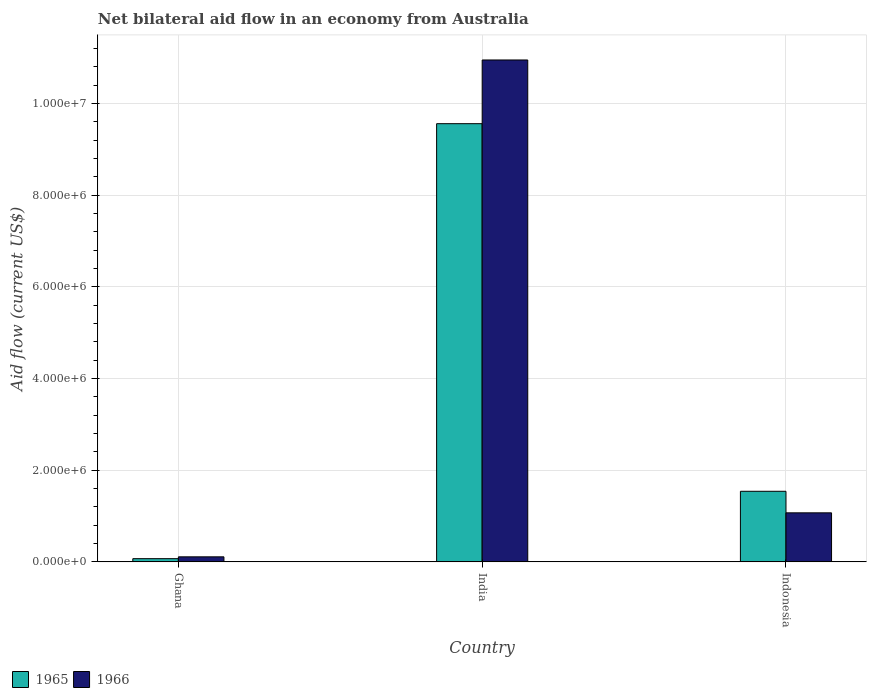How many groups of bars are there?
Provide a succinct answer. 3. What is the label of the 3rd group of bars from the left?
Your answer should be very brief. Indonesia. In how many cases, is the number of bars for a given country not equal to the number of legend labels?
Give a very brief answer. 0. What is the net bilateral aid flow in 1966 in India?
Provide a short and direct response. 1.10e+07. Across all countries, what is the maximum net bilateral aid flow in 1965?
Provide a short and direct response. 9.56e+06. Across all countries, what is the minimum net bilateral aid flow in 1965?
Provide a succinct answer. 7.00e+04. What is the total net bilateral aid flow in 1965 in the graph?
Provide a short and direct response. 1.12e+07. What is the difference between the net bilateral aid flow in 1965 in India and that in Indonesia?
Keep it short and to the point. 8.02e+06. What is the difference between the net bilateral aid flow in 1965 in Indonesia and the net bilateral aid flow in 1966 in India?
Provide a succinct answer. -9.41e+06. What is the average net bilateral aid flow in 1966 per country?
Your answer should be very brief. 4.04e+06. What is the difference between the net bilateral aid flow of/in 1966 and net bilateral aid flow of/in 1965 in Ghana?
Give a very brief answer. 4.00e+04. What is the ratio of the net bilateral aid flow in 1965 in Ghana to that in Indonesia?
Give a very brief answer. 0.05. Is the difference between the net bilateral aid flow in 1966 in Ghana and Indonesia greater than the difference between the net bilateral aid flow in 1965 in Ghana and Indonesia?
Make the answer very short. Yes. What is the difference between the highest and the second highest net bilateral aid flow in 1965?
Provide a short and direct response. 9.49e+06. What is the difference between the highest and the lowest net bilateral aid flow in 1966?
Your answer should be very brief. 1.08e+07. Is the sum of the net bilateral aid flow in 1966 in Ghana and India greater than the maximum net bilateral aid flow in 1965 across all countries?
Your answer should be compact. Yes. What does the 2nd bar from the left in India represents?
Provide a succinct answer. 1966. What does the 1st bar from the right in India represents?
Your answer should be very brief. 1966. What is the difference between two consecutive major ticks on the Y-axis?
Your response must be concise. 2.00e+06. Does the graph contain grids?
Offer a terse response. Yes. Where does the legend appear in the graph?
Keep it short and to the point. Bottom left. How are the legend labels stacked?
Ensure brevity in your answer.  Horizontal. What is the title of the graph?
Your response must be concise. Net bilateral aid flow in an economy from Australia. Does "1987" appear as one of the legend labels in the graph?
Give a very brief answer. No. What is the label or title of the X-axis?
Keep it short and to the point. Country. What is the Aid flow (current US$) in 1966 in Ghana?
Ensure brevity in your answer.  1.10e+05. What is the Aid flow (current US$) in 1965 in India?
Offer a very short reply. 9.56e+06. What is the Aid flow (current US$) in 1966 in India?
Keep it short and to the point. 1.10e+07. What is the Aid flow (current US$) of 1965 in Indonesia?
Your response must be concise. 1.54e+06. What is the Aid flow (current US$) of 1966 in Indonesia?
Give a very brief answer. 1.07e+06. Across all countries, what is the maximum Aid flow (current US$) in 1965?
Ensure brevity in your answer.  9.56e+06. Across all countries, what is the maximum Aid flow (current US$) of 1966?
Your answer should be compact. 1.10e+07. Across all countries, what is the minimum Aid flow (current US$) of 1965?
Keep it short and to the point. 7.00e+04. Across all countries, what is the minimum Aid flow (current US$) in 1966?
Your response must be concise. 1.10e+05. What is the total Aid flow (current US$) of 1965 in the graph?
Provide a short and direct response. 1.12e+07. What is the total Aid flow (current US$) in 1966 in the graph?
Give a very brief answer. 1.21e+07. What is the difference between the Aid flow (current US$) in 1965 in Ghana and that in India?
Ensure brevity in your answer.  -9.49e+06. What is the difference between the Aid flow (current US$) of 1966 in Ghana and that in India?
Your response must be concise. -1.08e+07. What is the difference between the Aid flow (current US$) of 1965 in Ghana and that in Indonesia?
Provide a succinct answer. -1.47e+06. What is the difference between the Aid flow (current US$) of 1966 in Ghana and that in Indonesia?
Make the answer very short. -9.60e+05. What is the difference between the Aid flow (current US$) of 1965 in India and that in Indonesia?
Provide a succinct answer. 8.02e+06. What is the difference between the Aid flow (current US$) in 1966 in India and that in Indonesia?
Offer a very short reply. 9.88e+06. What is the difference between the Aid flow (current US$) in 1965 in Ghana and the Aid flow (current US$) in 1966 in India?
Keep it short and to the point. -1.09e+07. What is the difference between the Aid flow (current US$) in 1965 in Ghana and the Aid flow (current US$) in 1966 in Indonesia?
Ensure brevity in your answer.  -1.00e+06. What is the difference between the Aid flow (current US$) in 1965 in India and the Aid flow (current US$) in 1966 in Indonesia?
Your answer should be compact. 8.49e+06. What is the average Aid flow (current US$) of 1965 per country?
Ensure brevity in your answer.  3.72e+06. What is the average Aid flow (current US$) of 1966 per country?
Give a very brief answer. 4.04e+06. What is the difference between the Aid flow (current US$) of 1965 and Aid flow (current US$) of 1966 in Ghana?
Provide a succinct answer. -4.00e+04. What is the difference between the Aid flow (current US$) of 1965 and Aid flow (current US$) of 1966 in India?
Offer a very short reply. -1.39e+06. What is the difference between the Aid flow (current US$) of 1965 and Aid flow (current US$) of 1966 in Indonesia?
Provide a succinct answer. 4.70e+05. What is the ratio of the Aid flow (current US$) of 1965 in Ghana to that in India?
Offer a terse response. 0.01. What is the ratio of the Aid flow (current US$) of 1966 in Ghana to that in India?
Offer a terse response. 0.01. What is the ratio of the Aid flow (current US$) in 1965 in Ghana to that in Indonesia?
Offer a terse response. 0.05. What is the ratio of the Aid flow (current US$) in 1966 in Ghana to that in Indonesia?
Ensure brevity in your answer.  0.1. What is the ratio of the Aid flow (current US$) in 1965 in India to that in Indonesia?
Give a very brief answer. 6.21. What is the ratio of the Aid flow (current US$) in 1966 in India to that in Indonesia?
Keep it short and to the point. 10.23. What is the difference between the highest and the second highest Aid flow (current US$) in 1965?
Make the answer very short. 8.02e+06. What is the difference between the highest and the second highest Aid flow (current US$) in 1966?
Offer a very short reply. 9.88e+06. What is the difference between the highest and the lowest Aid flow (current US$) in 1965?
Offer a very short reply. 9.49e+06. What is the difference between the highest and the lowest Aid flow (current US$) in 1966?
Ensure brevity in your answer.  1.08e+07. 